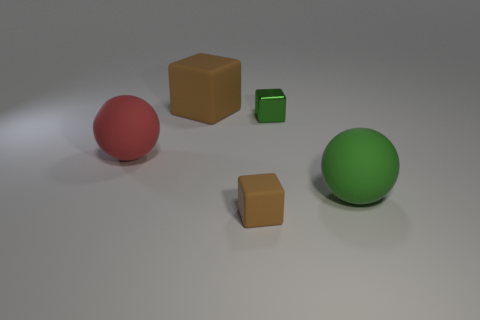Is the number of matte balls on the right side of the tiny green block greater than the number of big red rubber things that are behind the big block?
Offer a very short reply. Yes. There is a tiny brown rubber thing; are there any rubber blocks on the left side of it?
Give a very brief answer. Yes. There is a object that is on the right side of the small brown cube and behind the red matte thing; what is its material?
Keep it short and to the point. Metal. There is another small thing that is the same shape as the metal thing; what is its color?
Ensure brevity in your answer.  Brown. There is a big red ball that is in front of the green cube; is there a big object that is to the right of it?
Give a very brief answer. Yes. What is the size of the red rubber object?
Provide a succinct answer. Large. What shape is the rubber thing that is both to the right of the big brown object and to the left of the green rubber object?
Offer a very short reply. Cube. How many brown objects are either tiny rubber spheres or big cubes?
Give a very brief answer. 1. There is a object in front of the large green ball; is its size the same as the ball that is right of the large red object?
Keep it short and to the point. No. What number of things are either tiny brown rubber things or green balls?
Provide a short and direct response. 2. 